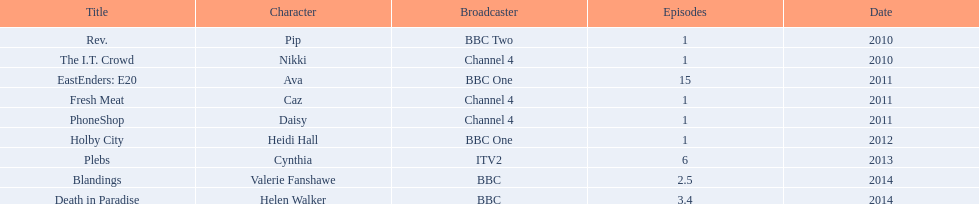What is the count of episodes that sophie colquhoun featured in on rev.? 1. What role did she assume in phoneshop? Daisy. What character did she enact on itv2? Cynthia. 